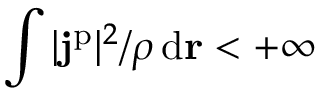<formula> <loc_0><loc_0><loc_500><loc_500>\int | j ^ { p } | ^ { 2 } / \rho \, d r < + \infty</formula> 